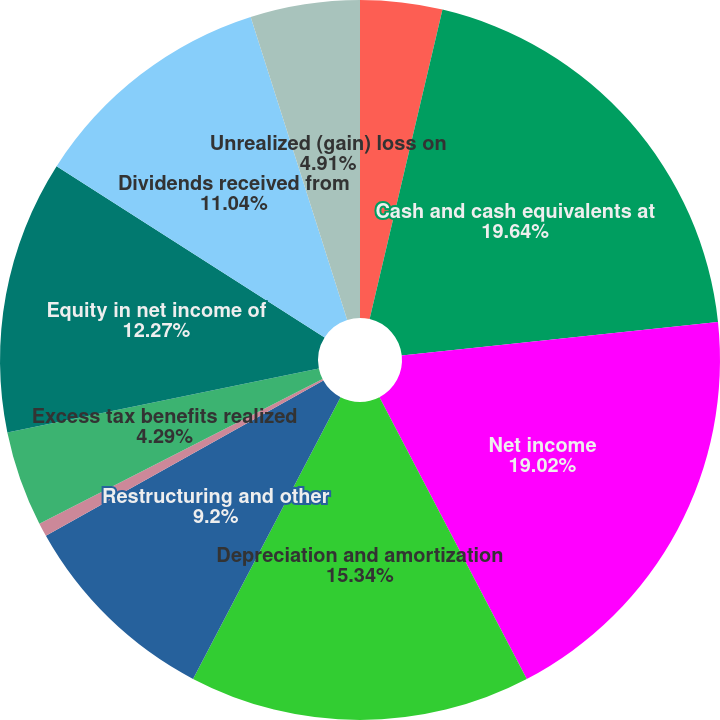Convert chart. <chart><loc_0><loc_0><loc_500><loc_500><pie_chart><fcel>(In Thousands) Year Ended<fcel>Cash and cash equivalents at<fcel>Net income<fcel>Depreciation and amortization<fcel>Restructuring and other<fcel>Stock-based compensation<fcel>Excess tax benefits realized<fcel>Equity in net income of<fcel>Dividends received from<fcel>Unrealized (gain) loss on<nl><fcel>3.68%<fcel>19.63%<fcel>19.02%<fcel>15.34%<fcel>9.2%<fcel>0.61%<fcel>4.29%<fcel>12.27%<fcel>11.04%<fcel>4.91%<nl></chart> 